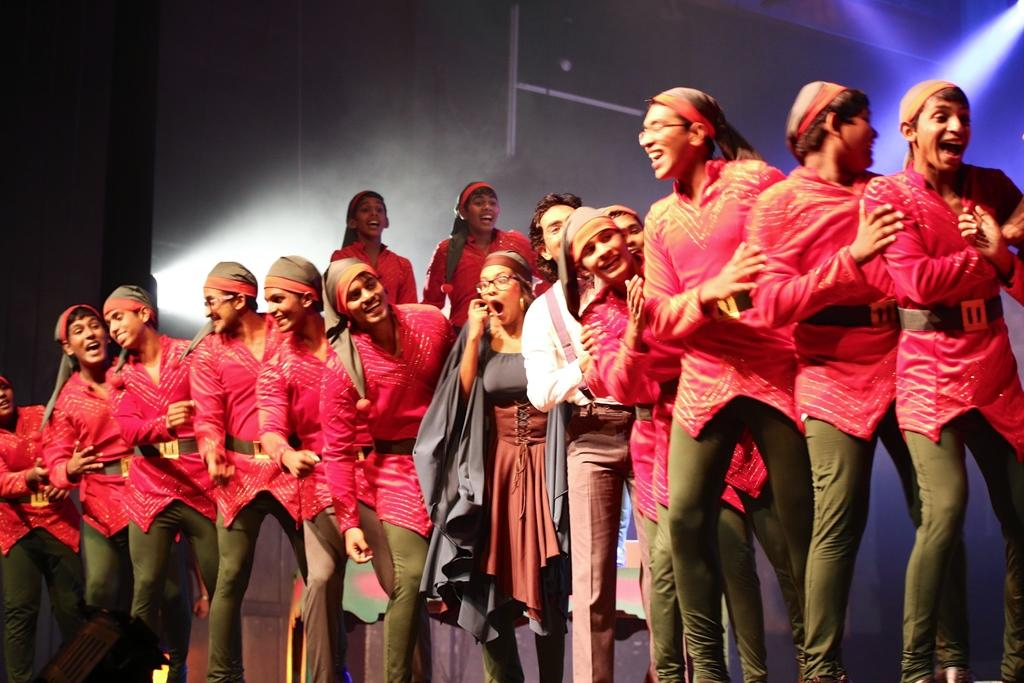What can be seen in the image? There are people standing in the image. What are the people wearing? The people are wearing costumes. What can be seen in the background of the image? There are lights visible in the background of the image. How much money is being exchanged between the people in the image? There is no indication of money being exchanged in the image; the people are wearing costumes and standing. What type of wrist accessory is visible on the people in the image? There is no mention of wrist accessories in the image; the focus is on the people wearing costumes. 